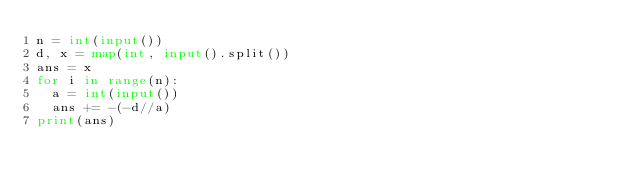Convert code to text. <code><loc_0><loc_0><loc_500><loc_500><_Python_>n = int(input())
d, x = map(int, input().split())
ans = x
for i in range(n):
  a = int(input())
  ans += -(-d//a)
print(ans)</code> 